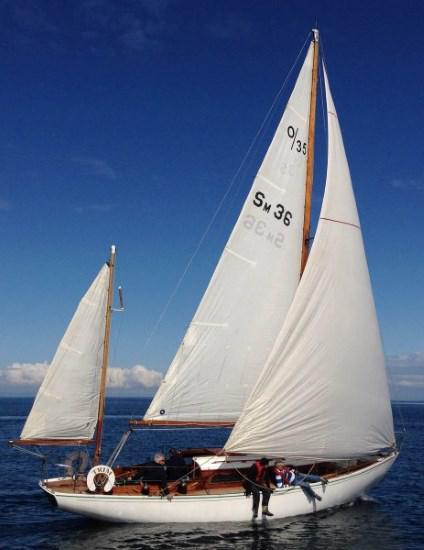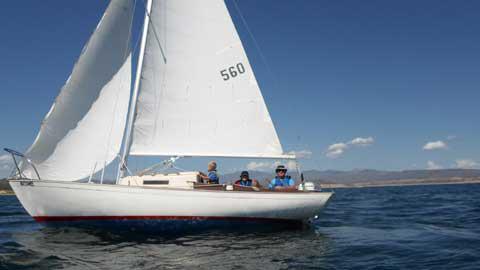The first image is the image on the left, the second image is the image on the right. Considering the images on both sides, is "A sailboat moving on deep-blue water has a non-white exterior boat body." valid? Answer yes or no. No. The first image is the image on the left, the second image is the image on the right. Considering the images on both sides, is "A landform sits in the distance behind the boat in the image on the left." valid? Answer yes or no. No. 